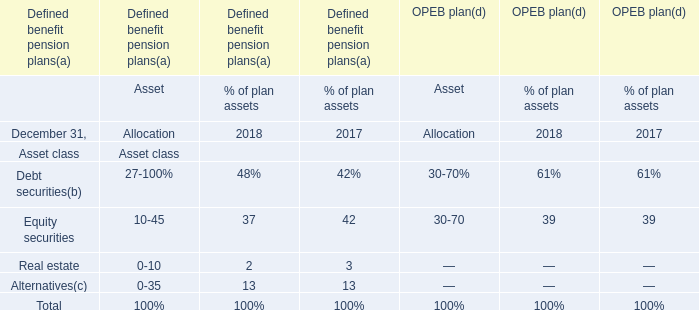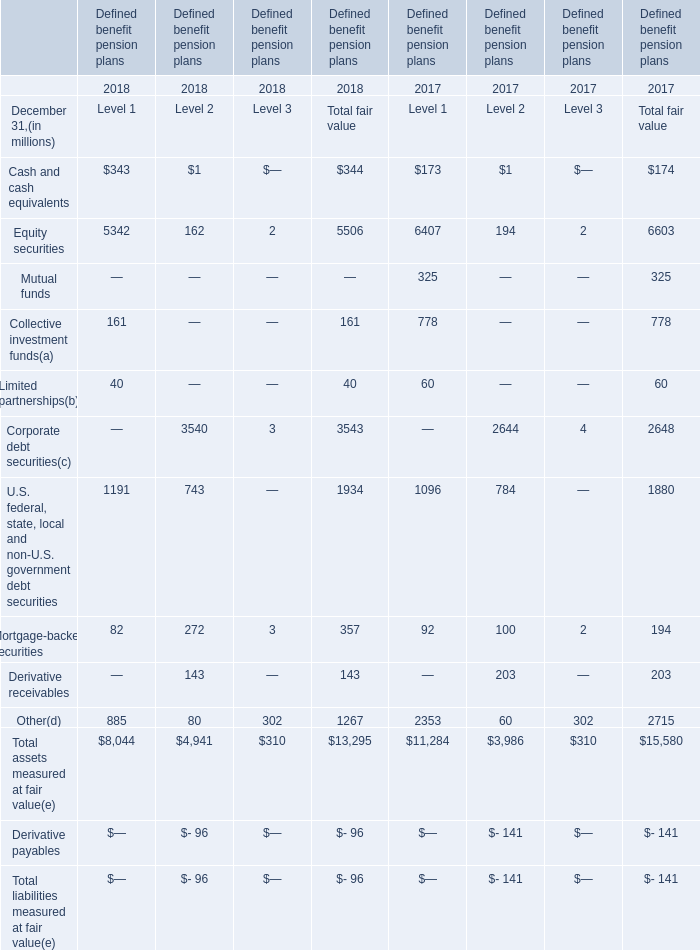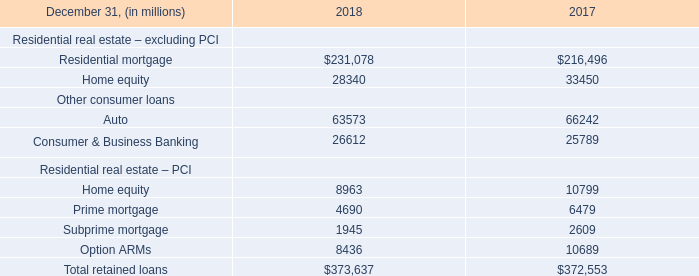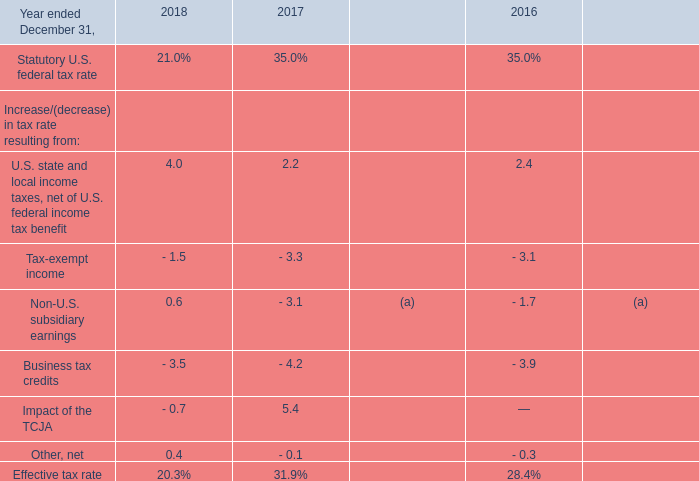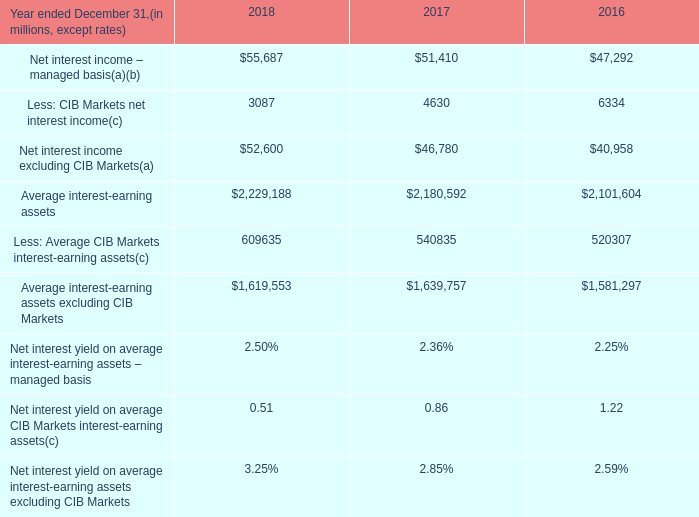What is the growing rate of Equity securities of Level 2 in Table 1 in the year with the most Other, net in Table 3? 
Computations: ((162 - 194) / 194)
Answer: -0.16495. 